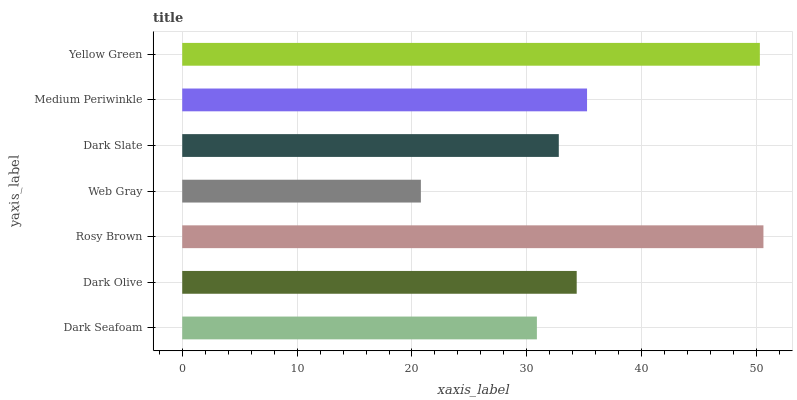Is Web Gray the minimum?
Answer yes or no. Yes. Is Rosy Brown the maximum?
Answer yes or no. Yes. Is Dark Olive the minimum?
Answer yes or no. No. Is Dark Olive the maximum?
Answer yes or no. No. Is Dark Olive greater than Dark Seafoam?
Answer yes or no. Yes. Is Dark Seafoam less than Dark Olive?
Answer yes or no. Yes. Is Dark Seafoam greater than Dark Olive?
Answer yes or no. No. Is Dark Olive less than Dark Seafoam?
Answer yes or no. No. Is Dark Olive the high median?
Answer yes or no. Yes. Is Dark Olive the low median?
Answer yes or no. Yes. Is Dark Seafoam the high median?
Answer yes or no. No. Is Rosy Brown the low median?
Answer yes or no. No. 